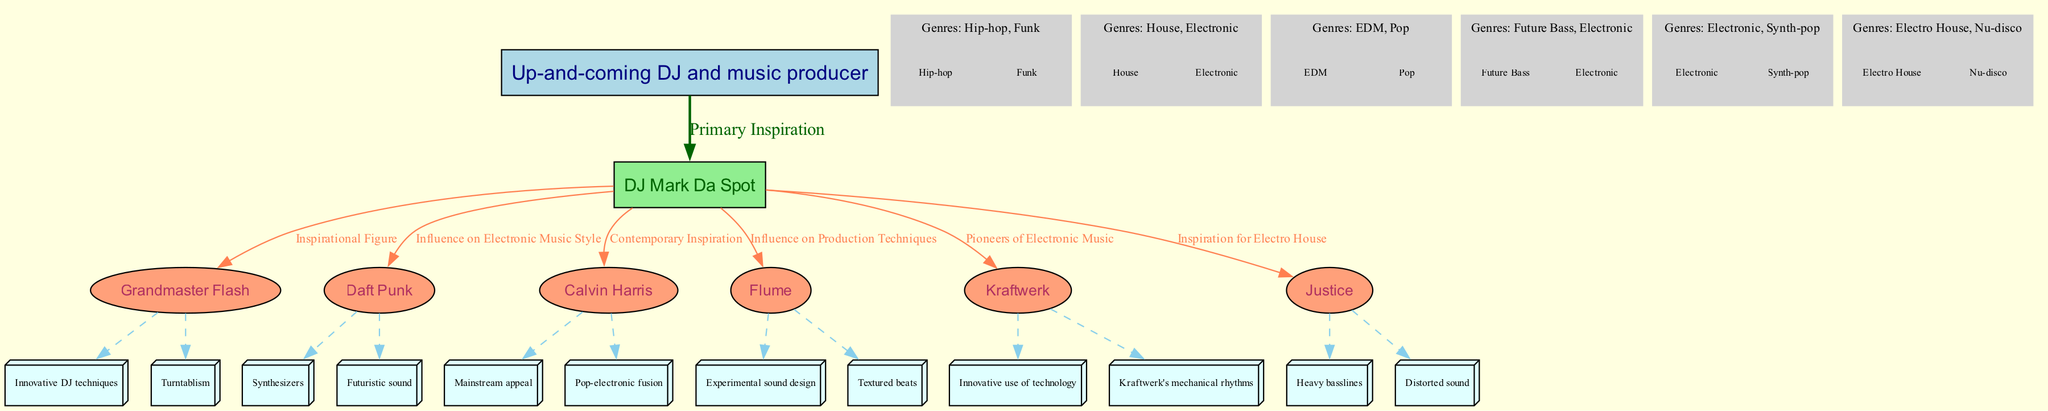What is the primary inspiration for the persona? The diagram indicates that DJ Mark Da Spot is labeled as the "Primary Inspiration" for the persona. This information can be found in the connection between the persona and DJ Mark Da Spot.
Answer: DJ Mark Da Spot How many influences are listed in the network? By counting the number of distinct individuals mentioned under "network_of_influences," we find seven influences listed, including both DJ Mark Da Spot and the other figures.
Answer: 7 Which genre is associated with Calvin Harris? The diagram lists "EDM" and "Pop" under Calvin Harris' genres in the subgraph dedicated to him. Therefore, either of these genres can be considered in answering the question.
Answer: EDM What relationship does Flume have with the persona? Flume is described as "Influence on Production Techniques" in the diagram. This description clearly outlines the type of influence Flume has on the persona's work.
Answer: Influence on Production Techniques Which artist is noted as a pioneer of electronic music? According to the diagram, Kraftwerk is specifically labeled as "Pioneers of Electronic Music", making them a significant figure in that context.
Answer: Kraftwerk How many genres are associated with Grandmaster Flash? The diagram shows that Grandmaster Flash is associated with two genres: "Hip-hop" and "Funk". The genres are listed under his subgraph, making the count straightforward.
Answer: 2 What is the influential aspect of Daft Punk? The diagram indicates that Daft Punk influences the persona's "Electronic Music Style" by focusing on elements such as "Synthesizers" and "Futuristic sound". This can be derived from the description provided.
Answer: Influence on Electronic Music Style Which two genres are mentioned under Justice? The subgraph connected to Justice lists "Electro House" and "Nu-disco" as the genres associated with this artist. This allows us to directly extract the information.
Answer: Electro House, Nu-disco What unique influence does Grandmaster Flash provide? Grandmaster Flash is noted for "Innovative DJ techniques" and "Turntablism," which highlight the specific skills he contributes to the DJing community and connection with the persona.
Answer: Innovative DJ techniques 